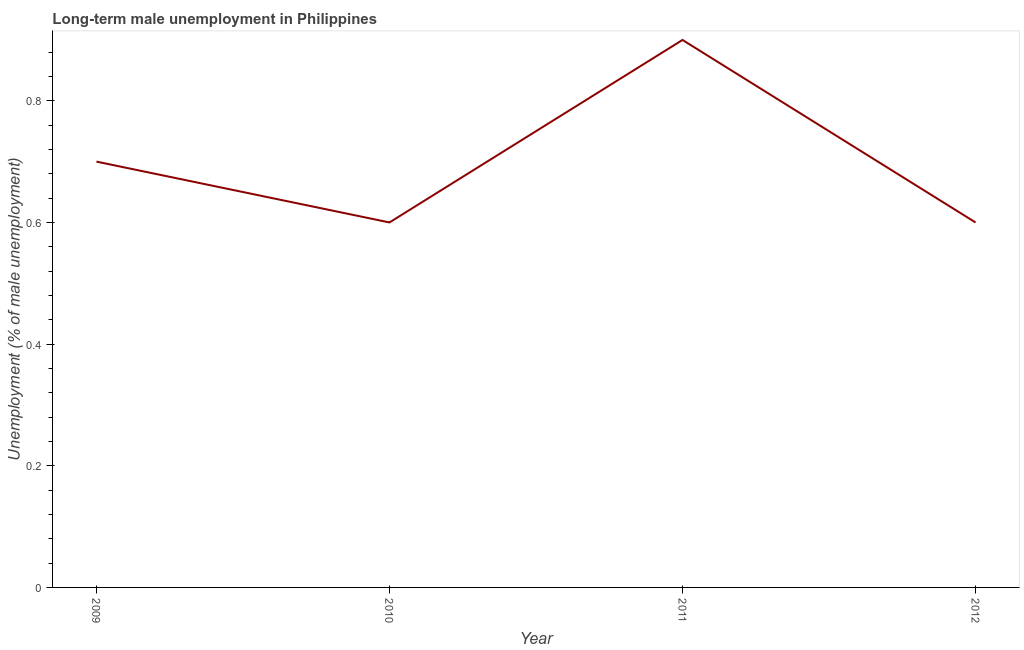What is the long-term male unemployment in 2010?
Your response must be concise. 0.6. Across all years, what is the maximum long-term male unemployment?
Provide a succinct answer. 0.9. Across all years, what is the minimum long-term male unemployment?
Your answer should be compact. 0.6. In which year was the long-term male unemployment maximum?
Provide a succinct answer. 2011. In which year was the long-term male unemployment minimum?
Give a very brief answer. 2010. What is the sum of the long-term male unemployment?
Provide a short and direct response. 2.8. What is the difference between the long-term male unemployment in 2011 and 2012?
Your answer should be compact. 0.3. What is the average long-term male unemployment per year?
Offer a very short reply. 0.7. What is the median long-term male unemployment?
Make the answer very short. 0.65. In how many years, is the long-term male unemployment greater than 0.48000000000000004 %?
Keep it short and to the point. 4. What is the ratio of the long-term male unemployment in 2010 to that in 2012?
Ensure brevity in your answer.  1. What is the difference between the highest and the second highest long-term male unemployment?
Give a very brief answer. 0.2. What is the difference between the highest and the lowest long-term male unemployment?
Provide a short and direct response. 0.3. What is the difference between two consecutive major ticks on the Y-axis?
Offer a very short reply. 0.2. Are the values on the major ticks of Y-axis written in scientific E-notation?
Provide a short and direct response. No. What is the title of the graph?
Offer a terse response. Long-term male unemployment in Philippines. What is the label or title of the X-axis?
Your response must be concise. Year. What is the label or title of the Y-axis?
Offer a very short reply. Unemployment (% of male unemployment). What is the Unemployment (% of male unemployment) of 2009?
Your answer should be compact. 0.7. What is the Unemployment (% of male unemployment) in 2010?
Offer a terse response. 0.6. What is the Unemployment (% of male unemployment) in 2011?
Your answer should be compact. 0.9. What is the Unemployment (% of male unemployment) of 2012?
Your response must be concise. 0.6. What is the difference between the Unemployment (% of male unemployment) in 2009 and 2012?
Provide a succinct answer. 0.1. What is the difference between the Unemployment (% of male unemployment) in 2010 and 2011?
Ensure brevity in your answer.  -0.3. What is the difference between the Unemployment (% of male unemployment) in 2010 and 2012?
Give a very brief answer. 0. What is the ratio of the Unemployment (% of male unemployment) in 2009 to that in 2010?
Keep it short and to the point. 1.17. What is the ratio of the Unemployment (% of male unemployment) in 2009 to that in 2011?
Your answer should be very brief. 0.78. What is the ratio of the Unemployment (% of male unemployment) in 2009 to that in 2012?
Offer a very short reply. 1.17. What is the ratio of the Unemployment (% of male unemployment) in 2010 to that in 2011?
Offer a very short reply. 0.67. What is the ratio of the Unemployment (% of male unemployment) in 2010 to that in 2012?
Ensure brevity in your answer.  1. What is the ratio of the Unemployment (% of male unemployment) in 2011 to that in 2012?
Make the answer very short. 1.5. 